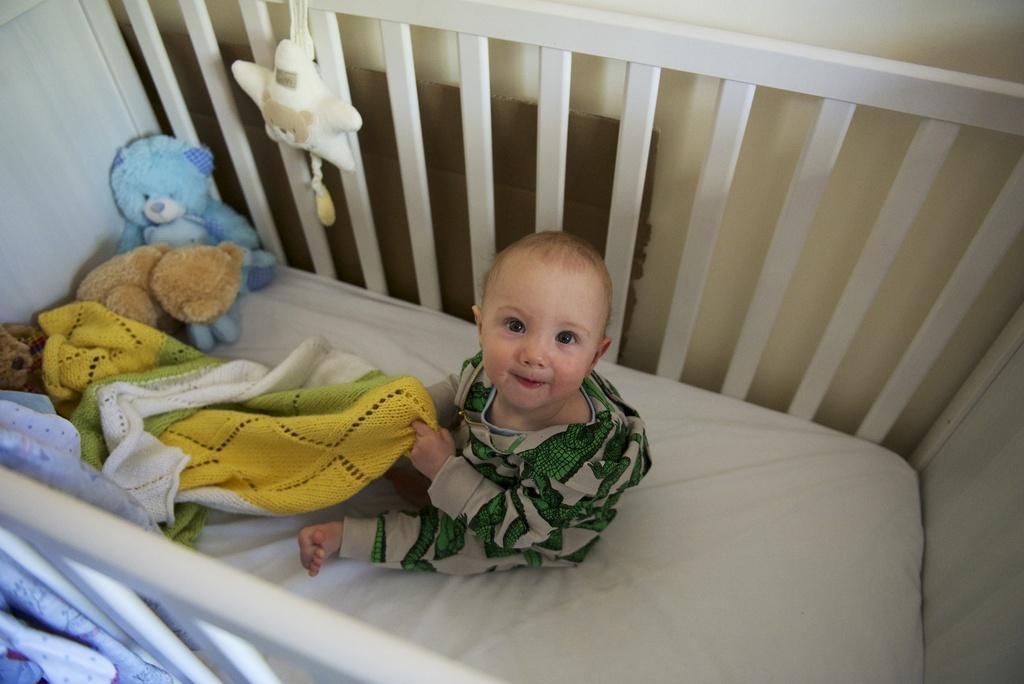Can you describe this image briefly? In this image there is a kid sitting on the bed holding towel in his hand. 